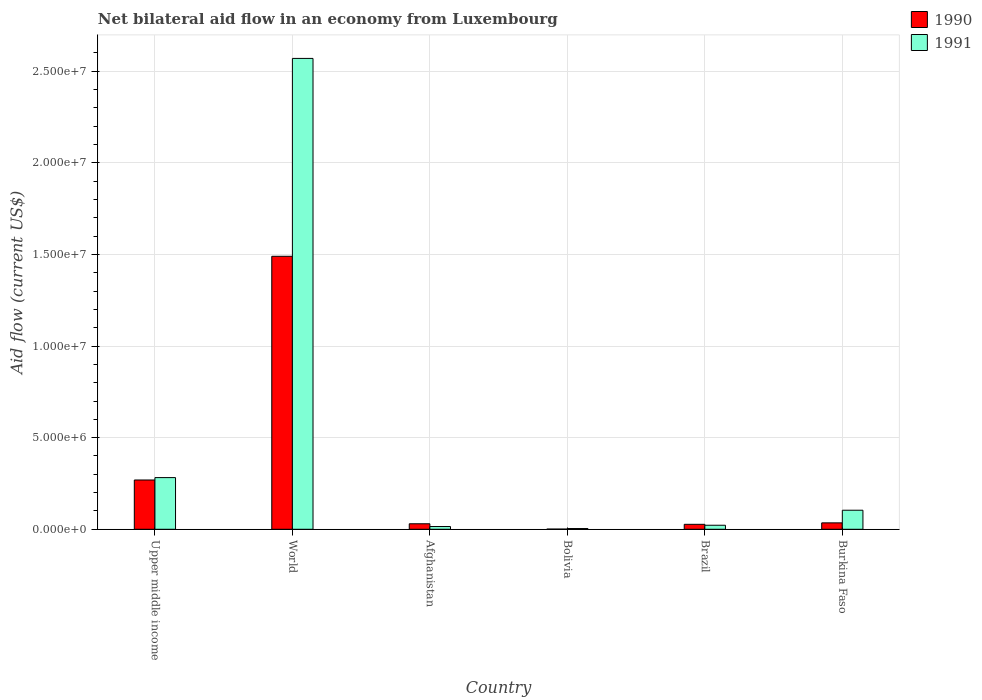How many different coloured bars are there?
Provide a succinct answer. 2. Are the number of bars on each tick of the X-axis equal?
Keep it short and to the point. Yes. How many bars are there on the 4th tick from the left?
Keep it short and to the point. 2. What is the label of the 4th group of bars from the left?
Provide a short and direct response. Bolivia. In how many cases, is the number of bars for a given country not equal to the number of legend labels?
Provide a short and direct response. 0. Across all countries, what is the maximum net bilateral aid flow in 1990?
Offer a terse response. 1.49e+07. What is the total net bilateral aid flow in 1991 in the graph?
Ensure brevity in your answer.  3.00e+07. What is the difference between the net bilateral aid flow in 1990 in Upper middle income and that in World?
Provide a succinct answer. -1.22e+07. What is the difference between the net bilateral aid flow in 1990 in Upper middle income and the net bilateral aid flow in 1991 in Bolivia?
Make the answer very short. 2.65e+06. What is the average net bilateral aid flow in 1990 per country?
Offer a very short reply. 3.09e+06. What is the difference between the net bilateral aid flow of/in 1990 and net bilateral aid flow of/in 1991 in Bolivia?
Give a very brief answer. -3.00e+04. What is the ratio of the net bilateral aid flow in 1991 in Upper middle income to that in World?
Offer a terse response. 0.11. Is the net bilateral aid flow in 1991 in Bolivia less than that in Burkina Faso?
Provide a short and direct response. Yes. Is the difference between the net bilateral aid flow in 1990 in Bolivia and Brazil greater than the difference between the net bilateral aid flow in 1991 in Bolivia and Brazil?
Make the answer very short. No. What is the difference between the highest and the second highest net bilateral aid flow in 1991?
Keep it short and to the point. 2.47e+07. What is the difference between the highest and the lowest net bilateral aid flow in 1991?
Your response must be concise. 2.57e+07. In how many countries, is the net bilateral aid flow in 1990 greater than the average net bilateral aid flow in 1990 taken over all countries?
Your answer should be compact. 1. Is the sum of the net bilateral aid flow in 1990 in Upper middle income and World greater than the maximum net bilateral aid flow in 1991 across all countries?
Offer a terse response. No. What does the 2nd bar from the left in Brazil represents?
Keep it short and to the point. 1991. Are all the bars in the graph horizontal?
Keep it short and to the point. No. Does the graph contain grids?
Make the answer very short. Yes. How many legend labels are there?
Offer a terse response. 2. How are the legend labels stacked?
Your answer should be very brief. Vertical. What is the title of the graph?
Keep it short and to the point. Net bilateral aid flow in an economy from Luxembourg. What is the label or title of the Y-axis?
Your answer should be compact. Aid flow (current US$). What is the Aid flow (current US$) in 1990 in Upper middle income?
Make the answer very short. 2.69e+06. What is the Aid flow (current US$) in 1991 in Upper middle income?
Make the answer very short. 2.82e+06. What is the Aid flow (current US$) in 1990 in World?
Provide a short and direct response. 1.49e+07. What is the Aid flow (current US$) in 1991 in World?
Your answer should be compact. 2.57e+07. What is the Aid flow (current US$) of 1991 in Bolivia?
Your answer should be very brief. 4.00e+04. What is the Aid flow (current US$) of 1990 in Brazil?
Ensure brevity in your answer.  2.70e+05. What is the Aid flow (current US$) of 1991 in Burkina Faso?
Offer a terse response. 1.04e+06. Across all countries, what is the maximum Aid flow (current US$) in 1990?
Your answer should be very brief. 1.49e+07. Across all countries, what is the maximum Aid flow (current US$) of 1991?
Make the answer very short. 2.57e+07. Across all countries, what is the minimum Aid flow (current US$) in 1990?
Give a very brief answer. 10000. Across all countries, what is the minimum Aid flow (current US$) in 1991?
Provide a short and direct response. 4.00e+04. What is the total Aid flow (current US$) of 1990 in the graph?
Ensure brevity in your answer.  1.85e+07. What is the total Aid flow (current US$) of 1991 in the graph?
Your answer should be compact. 3.00e+07. What is the difference between the Aid flow (current US$) of 1990 in Upper middle income and that in World?
Offer a very short reply. -1.22e+07. What is the difference between the Aid flow (current US$) of 1991 in Upper middle income and that in World?
Make the answer very short. -2.29e+07. What is the difference between the Aid flow (current US$) of 1990 in Upper middle income and that in Afghanistan?
Provide a succinct answer. 2.39e+06. What is the difference between the Aid flow (current US$) of 1991 in Upper middle income and that in Afghanistan?
Make the answer very short. 2.67e+06. What is the difference between the Aid flow (current US$) in 1990 in Upper middle income and that in Bolivia?
Make the answer very short. 2.68e+06. What is the difference between the Aid flow (current US$) of 1991 in Upper middle income and that in Bolivia?
Ensure brevity in your answer.  2.78e+06. What is the difference between the Aid flow (current US$) in 1990 in Upper middle income and that in Brazil?
Your answer should be very brief. 2.42e+06. What is the difference between the Aid flow (current US$) in 1991 in Upper middle income and that in Brazil?
Offer a very short reply. 2.60e+06. What is the difference between the Aid flow (current US$) of 1990 in Upper middle income and that in Burkina Faso?
Keep it short and to the point. 2.34e+06. What is the difference between the Aid flow (current US$) of 1991 in Upper middle income and that in Burkina Faso?
Give a very brief answer. 1.78e+06. What is the difference between the Aid flow (current US$) of 1990 in World and that in Afghanistan?
Your response must be concise. 1.46e+07. What is the difference between the Aid flow (current US$) in 1991 in World and that in Afghanistan?
Your response must be concise. 2.56e+07. What is the difference between the Aid flow (current US$) of 1990 in World and that in Bolivia?
Provide a short and direct response. 1.49e+07. What is the difference between the Aid flow (current US$) of 1991 in World and that in Bolivia?
Your answer should be very brief. 2.57e+07. What is the difference between the Aid flow (current US$) of 1990 in World and that in Brazil?
Offer a very short reply. 1.46e+07. What is the difference between the Aid flow (current US$) of 1991 in World and that in Brazil?
Keep it short and to the point. 2.55e+07. What is the difference between the Aid flow (current US$) in 1990 in World and that in Burkina Faso?
Your response must be concise. 1.46e+07. What is the difference between the Aid flow (current US$) of 1991 in World and that in Burkina Faso?
Keep it short and to the point. 2.47e+07. What is the difference between the Aid flow (current US$) of 1990 in Afghanistan and that in Bolivia?
Your answer should be compact. 2.90e+05. What is the difference between the Aid flow (current US$) in 1990 in Afghanistan and that in Brazil?
Provide a short and direct response. 3.00e+04. What is the difference between the Aid flow (current US$) in 1991 in Afghanistan and that in Brazil?
Offer a terse response. -7.00e+04. What is the difference between the Aid flow (current US$) of 1991 in Afghanistan and that in Burkina Faso?
Your answer should be compact. -8.90e+05. What is the difference between the Aid flow (current US$) in 1990 in Bolivia and that in Brazil?
Your answer should be very brief. -2.60e+05. What is the difference between the Aid flow (current US$) in 1990 in Bolivia and that in Burkina Faso?
Make the answer very short. -3.40e+05. What is the difference between the Aid flow (current US$) in 1990 in Brazil and that in Burkina Faso?
Provide a short and direct response. -8.00e+04. What is the difference between the Aid flow (current US$) in 1991 in Brazil and that in Burkina Faso?
Your answer should be compact. -8.20e+05. What is the difference between the Aid flow (current US$) in 1990 in Upper middle income and the Aid flow (current US$) in 1991 in World?
Provide a short and direct response. -2.30e+07. What is the difference between the Aid flow (current US$) of 1990 in Upper middle income and the Aid flow (current US$) of 1991 in Afghanistan?
Make the answer very short. 2.54e+06. What is the difference between the Aid flow (current US$) of 1990 in Upper middle income and the Aid flow (current US$) of 1991 in Bolivia?
Your answer should be compact. 2.65e+06. What is the difference between the Aid flow (current US$) in 1990 in Upper middle income and the Aid flow (current US$) in 1991 in Brazil?
Make the answer very short. 2.47e+06. What is the difference between the Aid flow (current US$) of 1990 in Upper middle income and the Aid flow (current US$) of 1991 in Burkina Faso?
Offer a terse response. 1.65e+06. What is the difference between the Aid flow (current US$) in 1990 in World and the Aid flow (current US$) in 1991 in Afghanistan?
Keep it short and to the point. 1.48e+07. What is the difference between the Aid flow (current US$) in 1990 in World and the Aid flow (current US$) in 1991 in Bolivia?
Offer a terse response. 1.49e+07. What is the difference between the Aid flow (current US$) in 1990 in World and the Aid flow (current US$) in 1991 in Brazil?
Make the answer very short. 1.47e+07. What is the difference between the Aid flow (current US$) in 1990 in World and the Aid flow (current US$) in 1991 in Burkina Faso?
Keep it short and to the point. 1.39e+07. What is the difference between the Aid flow (current US$) in 1990 in Afghanistan and the Aid flow (current US$) in 1991 in Bolivia?
Your answer should be compact. 2.60e+05. What is the difference between the Aid flow (current US$) of 1990 in Afghanistan and the Aid flow (current US$) of 1991 in Brazil?
Make the answer very short. 8.00e+04. What is the difference between the Aid flow (current US$) in 1990 in Afghanistan and the Aid flow (current US$) in 1991 in Burkina Faso?
Offer a terse response. -7.40e+05. What is the difference between the Aid flow (current US$) in 1990 in Bolivia and the Aid flow (current US$) in 1991 in Burkina Faso?
Offer a terse response. -1.03e+06. What is the difference between the Aid flow (current US$) of 1990 in Brazil and the Aid flow (current US$) of 1991 in Burkina Faso?
Offer a very short reply. -7.70e+05. What is the average Aid flow (current US$) in 1990 per country?
Provide a short and direct response. 3.09e+06. What is the average Aid flow (current US$) of 1991 per country?
Your answer should be very brief. 5.00e+06. What is the difference between the Aid flow (current US$) in 1990 and Aid flow (current US$) in 1991 in Upper middle income?
Your answer should be compact. -1.30e+05. What is the difference between the Aid flow (current US$) in 1990 and Aid flow (current US$) in 1991 in World?
Make the answer very short. -1.08e+07. What is the difference between the Aid flow (current US$) in 1990 and Aid flow (current US$) in 1991 in Afghanistan?
Make the answer very short. 1.50e+05. What is the difference between the Aid flow (current US$) of 1990 and Aid flow (current US$) of 1991 in Burkina Faso?
Offer a very short reply. -6.90e+05. What is the ratio of the Aid flow (current US$) of 1990 in Upper middle income to that in World?
Make the answer very short. 0.18. What is the ratio of the Aid flow (current US$) of 1991 in Upper middle income to that in World?
Ensure brevity in your answer.  0.11. What is the ratio of the Aid flow (current US$) in 1990 in Upper middle income to that in Afghanistan?
Your answer should be very brief. 8.97. What is the ratio of the Aid flow (current US$) of 1991 in Upper middle income to that in Afghanistan?
Offer a very short reply. 18.8. What is the ratio of the Aid flow (current US$) in 1990 in Upper middle income to that in Bolivia?
Offer a terse response. 269. What is the ratio of the Aid flow (current US$) in 1991 in Upper middle income to that in Bolivia?
Provide a short and direct response. 70.5. What is the ratio of the Aid flow (current US$) in 1990 in Upper middle income to that in Brazil?
Ensure brevity in your answer.  9.96. What is the ratio of the Aid flow (current US$) in 1991 in Upper middle income to that in Brazil?
Give a very brief answer. 12.82. What is the ratio of the Aid flow (current US$) in 1990 in Upper middle income to that in Burkina Faso?
Offer a terse response. 7.69. What is the ratio of the Aid flow (current US$) in 1991 in Upper middle income to that in Burkina Faso?
Provide a succinct answer. 2.71. What is the ratio of the Aid flow (current US$) in 1990 in World to that in Afghanistan?
Make the answer very short. 49.67. What is the ratio of the Aid flow (current US$) of 1991 in World to that in Afghanistan?
Ensure brevity in your answer.  171.33. What is the ratio of the Aid flow (current US$) in 1990 in World to that in Bolivia?
Make the answer very short. 1490. What is the ratio of the Aid flow (current US$) in 1991 in World to that in Bolivia?
Offer a very short reply. 642.5. What is the ratio of the Aid flow (current US$) of 1990 in World to that in Brazil?
Your answer should be compact. 55.19. What is the ratio of the Aid flow (current US$) in 1991 in World to that in Brazil?
Offer a very short reply. 116.82. What is the ratio of the Aid flow (current US$) in 1990 in World to that in Burkina Faso?
Ensure brevity in your answer.  42.57. What is the ratio of the Aid flow (current US$) in 1991 in World to that in Burkina Faso?
Make the answer very short. 24.71. What is the ratio of the Aid flow (current US$) of 1990 in Afghanistan to that in Bolivia?
Your answer should be very brief. 30. What is the ratio of the Aid flow (current US$) in 1991 in Afghanistan to that in Bolivia?
Make the answer very short. 3.75. What is the ratio of the Aid flow (current US$) of 1990 in Afghanistan to that in Brazil?
Your response must be concise. 1.11. What is the ratio of the Aid flow (current US$) of 1991 in Afghanistan to that in Brazil?
Provide a short and direct response. 0.68. What is the ratio of the Aid flow (current US$) in 1991 in Afghanistan to that in Burkina Faso?
Offer a terse response. 0.14. What is the ratio of the Aid flow (current US$) in 1990 in Bolivia to that in Brazil?
Keep it short and to the point. 0.04. What is the ratio of the Aid flow (current US$) in 1991 in Bolivia to that in Brazil?
Offer a very short reply. 0.18. What is the ratio of the Aid flow (current US$) of 1990 in Bolivia to that in Burkina Faso?
Make the answer very short. 0.03. What is the ratio of the Aid flow (current US$) of 1991 in Bolivia to that in Burkina Faso?
Offer a terse response. 0.04. What is the ratio of the Aid flow (current US$) of 1990 in Brazil to that in Burkina Faso?
Your response must be concise. 0.77. What is the ratio of the Aid flow (current US$) of 1991 in Brazil to that in Burkina Faso?
Your answer should be very brief. 0.21. What is the difference between the highest and the second highest Aid flow (current US$) of 1990?
Provide a succinct answer. 1.22e+07. What is the difference between the highest and the second highest Aid flow (current US$) of 1991?
Give a very brief answer. 2.29e+07. What is the difference between the highest and the lowest Aid flow (current US$) of 1990?
Keep it short and to the point. 1.49e+07. What is the difference between the highest and the lowest Aid flow (current US$) in 1991?
Ensure brevity in your answer.  2.57e+07. 